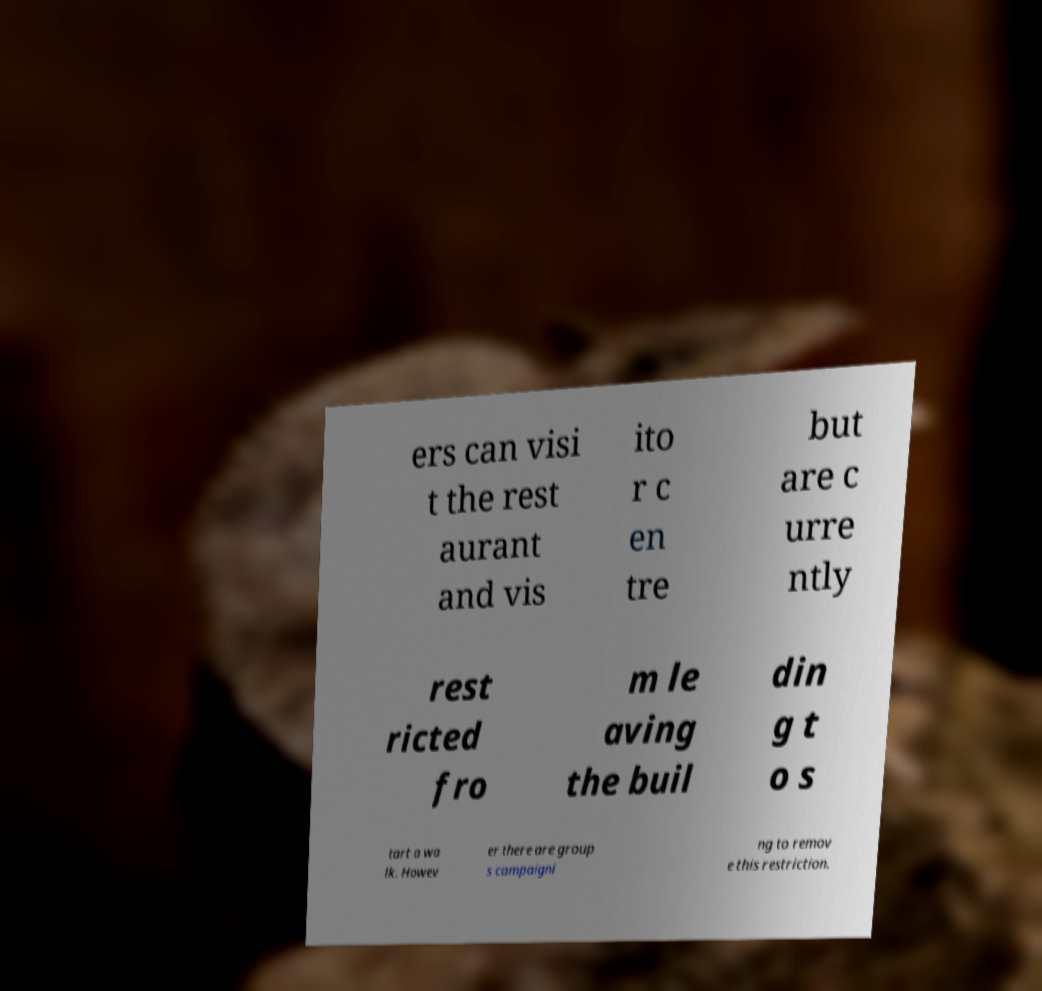Could you extract and type out the text from this image? ers can visi t the rest aurant and vis ito r c en tre but are c urre ntly rest ricted fro m le aving the buil din g t o s tart a wa lk. Howev er there are group s campaigni ng to remov e this restriction. 